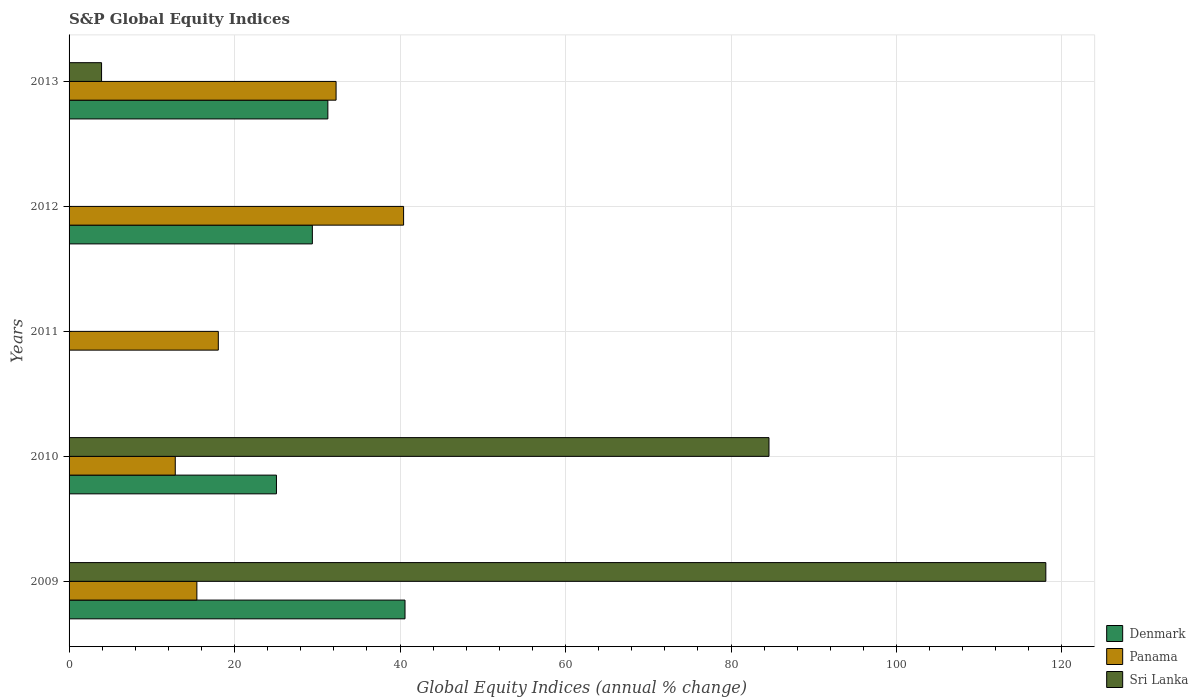How many different coloured bars are there?
Provide a succinct answer. 3. How many bars are there on the 1st tick from the top?
Your answer should be very brief. 3. What is the label of the 4th group of bars from the top?
Your answer should be compact. 2010. What is the global equity indices in Denmark in 2009?
Make the answer very short. 40.6. Across all years, what is the maximum global equity indices in Panama?
Offer a very short reply. 40.43. Across all years, what is the minimum global equity indices in Sri Lanka?
Keep it short and to the point. 0. In which year was the global equity indices in Panama maximum?
Your answer should be very brief. 2012. What is the total global equity indices in Denmark in the graph?
Your answer should be very brief. 126.35. What is the difference between the global equity indices in Panama in 2011 and that in 2012?
Give a very brief answer. -22.39. What is the difference between the global equity indices in Panama in 2009 and the global equity indices in Denmark in 2012?
Your answer should be compact. -13.96. What is the average global equity indices in Panama per year?
Provide a short and direct response. 23.8. In the year 2010, what is the difference between the global equity indices in Sri Lanka and global equity indices in Denmark?
Ensure brevity in your answer.  59.53. In how many years, is the global equity indices in Panama greater than 56 %?
Keep it short and to the point. 0. What is the ratio of the global equity indices in Panama in 2010 to that in 2012?
Your response must be concise. 0.32. Is the global equity indices in Denmark in 2009 less than that in 2010?
Provide a succinct answer. No. What is the difference between the highest and the second highest global equity indices in Sri Lanka?
Offer a terse response. 33.46. What is the difference between the highest and the lowest global equity indices in Panama?
Provide a succinct answer. 27.59. Is it the case that in every year, the sum of the global equity indices in Denmark and global equity indices in Panama is greater than the global equity indices in Sri Lanka?
Your answer should be very brief. No. How many bars are there?
Your response must be concise. 12. Are all the bars in the graph horizontal?
Your response must be concise. Yes. How many years are there in the graph?
Provide a short and direct response. 5. Does the graph contain grids?
Offer a terse response. Yes. Where does the legend appear in the graph?
Your answer should be very brief. Bottom right. How many legend labels are there?
Offer a very short reply. 3. What is the title of the graph?
Keep it short and to the point. S&P Global Equity Indices. Does "Sweden" appear as one of the legend labels in the graph?
Offer a terse response. No. What is the label or title of the X-axis?
Ensure brevity in your answer.  Global Equity Indices (annual % change). What is the Global Equity Indices (annual % change) in Denmark in 2009?
Your answer should be compact. 40.6. What is the Global Equity Indices (annual % change) in Panama in 2009?
Keep it short and to the point. 15.45. What is the Global Equity Indices (annual % change) of Sri Lanka in 2009?
Give a very brief answer. 118.05. What is the Global Equity Indices (annual % change) in Denmark in 2010?
Your answer should be very brief. 25.06. What is the Global Equity Indices (annual % change) of Panama in 2010?
Your answer should be compact. 12.83. What is the Global Equity Indices (annual % change) in Sri Lanka in 2010?
Your answer should be very brief. 84.59. What is the Global Equity Indices (annual % change) of Denmark in 2011?
Your answer should be compact. 0. What is the Global Equity Indices (annual % change) in Panama in 2011?
Your answer should be compact. 18.04. What is the Global Equity Indices (annual % change) in Denmark in 2012?
Keep it short and to the point. 29.4. What is the Global Equity Indices (annual % change) of Panama in 2012?
Offer a very short reply. 40.43. What is the Global Equity Indices (annual % change) of Sri Lanka in 2012?
Make the answer very short. 0. What is the Global Equity Indices (annual % change) in Denmark in 2013?
Offer a very short reply. 31.28. What is the Global Equity Indices (annual % change) in Panama in 2013?
Your answer should be very brief. 32.27. What is the Global Equity Indices (annual % change) in Sri Lanka in 2013?
Give a very brief answer. 3.93. Across all years, what is the maximum Global Equity Indices (annual % change) of Denmark?
Your answer should be very brief. 40.6. Across all years, what is the maximum Global Equity Indices (annual % change) of Panama?
Your answer should be very brief. 40.43. Across all years, what is the maximum Global Equity Indices (annual % change) of Sri Lanka?
Give a very brief answer. 118.05. Across all years, what is the minimum Global Equity Indices (annual % change) of Panama?
Offer a terse response. 12.83. Across all years, what is the minimum Global Equity Indices (annual % change) in Sri Lanka?
Offer a terse response. 0. What is the total Global Equity Indices (annual % change) in Denmark in the graph?
Give a very brief answer. 126.35. What is the total Global Equity Indices (annual % change) of Panama in the graph?
Give a very brief answer. 119.02. What is the total Global Equity Indices (annual % change) in Sri Lanka in the graph?
Your answer should be compact. 206.57. What is the difference between the Global Equity Indices (annual % change) of Denmark in 2009 and that in 2010?
Your answer should be compact. 15.54. What is the difference between the Global Equity Indices (annual % change) of Panama in 2009 and that in 2010?
Your answer should be very brief. 2.61. What is the difference between the Global Equity Indices (annual % change) in Sri Lanka in 2009 and that in 2010?
Your answer should be compact. 33.46. What is the difference between the Global Equity Indices (annual % change) in Panama in 2009 and that in 2011?
Offer a terse response. -2.59. What is the difference between the Global Equity Indices (annual % change) of Denmark in 2009 and that in 2012?
Offer a very short reply. 11.2. What is the difference between the Global Equity Indices (annual % change) in Panama in 2009 and that in 2012?
Offer a terse response. -24.98. What is the difference between the Global Equity Indices (annual % change) in Denmark in 2009 and that in 2013?
Ensure brevity in your answer.  9.33. What is the difference between the Global Equity Indices (annual % change) in Panama in 2009 and that in 2013?
Ensure brevity in your answer.  -16.82. What is the difference between the Global Equity Indices (annual % change) of Sri Lanka in 2009 and that in 2013?
Your answer should be very brief. 114.12. What is the difference between the Global Equity Indices (annual % change) of Panama in 2010 and that in 2011?
Keep it short and to the point. -5.2. What is the difference between the Global Equity Indices (annual % change) in Denmark in 2010 and that in 2012?
Offer a very short reply. -4.34. What is the difference between the Global Equity Indices (annual % change) of Panama in 2010 and that in 2012?
Your response must be concise. -27.59. What is the difference between the Global Equity Indices (annual % change) in Denmark in 2010 and that in 2013?
Give a very brief answer. -6.21. What is the difference between the Global Equity Indices (annual % change) of Panama in 2010 and that in 2013?
Ensure brevity in your answer.  -19.44. What is the difference between the Global Equity Indices (annual % change) in Sri Lanka in 2010 and that in 2013?
Give a very brief answer. 80.66. What is the difference between the Global Equity Indices (annual % change) of Panama in 2011 and that in 2012?
Offer a very short reply. -22.39. What is the difference between the Global Equity Indices (annual % change) of Panama in 2011 and that in 2013?
Your answer should be compact. -14.23. What is the difference between the Global Equity Indices (annual % change) of Denmark in 2012 and that in 2013?
Ensure brevity in your answer.  -1.87. What is the difference between the Global Equity Indices (annual % change) in Panama in 2012 and that in 2013?
Your answer should be very brief. 8.16. What is the difference between the Global Equity Indices (annual % change) in Denmark in 2009 and the Global Equity Indices (annual % change) in Panama in 2010?
Provide a short and direct response. 27.77. What is the difference between the Global Equity Indices (annual % change) in Denmark in 2009 and the Global Equity Indices (annual % change) in Sri Lanka in 2010?
Provide a short and direct response. -43.99. What is the difference between the Global Equity Indices (annual % change) of Panama in 2009 and the Global Equity Indices (annual % change) of Sri Lanka in 2010?
Offer a terse response. -69.14. What is the difference between the Global Equity Indices (annual % change) in Denmark in 2009 and the Global Equity Indices (annual % change) in Panama in 2011?
Offer a terse response. 22.57. What is the difference between the Global Equity Indices (annual % change) of Denmark in 2009 and the Global Equity Indices (annual % change) of Panama in 2012?
Give a very brief answer. 0.17. What is the difference between the Global Equity Indices (annual % change) of Denmark in 2009 and the Global Equity Indices (annual % change) of Panama in 2013?
Give a very brief answer. 8.33. What is the difference between the Global Equity Indices (annual % change) of Denmark in 2009 and the Global Equity Indices (annual % change) of Sri Lanka in 2013?
Offer a terse response. 36.67. What is the difference between the Global Equity Indices (annual % change) in Panama in 2009 and the Global Equity Indices (annual % change) in Sri Lanka in 2013?
Make the answer very short. 11.52. What is the difference between the Global Equity Indices (annual % change) in Denmark in 2010 and the Global Equity Indices (annual % change) in Panama in 2011?
Provide a succinct answer. 7.03. What is the difference between the Global Equity Indices (annual % change) in Denmark in 2010 and the Global Equity Indices (annual % change) in Panama in 2012?
Give a very brief answer. -15.37. What is the difference between the Global Equity Indices (annual % change) of Denmark in 2010 and the Global Equity Indices (annual % change) of Panama in 2013?
Provide a short and direct response. -7.21. What is the difference between the Global Equity Indices (annual % change) in Denmark in 2010 and the Global Equity Indices (annual % change) in Sri Lanka in 2013?
Provide a succinct answer. 21.14. What is the difference between the Global Equity Indices (annual % change) in Panama in 2010 and the Global Equity Indices (annual % change) in Sri Lanka in 2013?
Ensure brevity in your answer.  8.91. What is the difference between the Global Equity Indices (annual % change) of Panama in 2011 and the Global Equity Indices (annual % change) of Sri Lanka in 2013?
Your answer should be compact. 14.11. What is the difference between the Global Equity Indices (annual % change) in Denmark in 2012 and the Global Equity Indices (annual % change) in Panama in 2013?
Keep it short and to the point. -2.87. What is the difference between the Global Equity Indices (annual % change) of Denmark in 2012 and the Global Equity Indices (annual % change) of Sri Lanka in 2013?
Your answer should be compact. 25.48. What is the difference between the Global Equity Indices (annual % change) in Panama in 2012 and the Global Equity Indices (annual % change) in Sri Lanka in 2013?
Provide a succinct answer. 36.5. What is the average Global Equity Indices (annual % change) in Denmark per year?
Give a very brief answer. 25.27. What is the average Global Equity Indices (annual % change) of Panama per year?
Make the answer very short. 23.8. What is the average Global Equity Indices (annual % change) in Sri Lanka per year?
Offer a terse response. 41.31. In the year 2009, what is the difference between the Global Equity Indices (annual % change) in Denmark and Global Equity Indices (annual % change) in Panama?
Your answer should be compact. 25.16. In the year 2009, what is the difference between the Global Equity Indices (annual % change) of Denmark and Global Equity Indices (annual % change) of Sri Lanka?
Offer a very short reply. -77.45. In the year 2009, what is the difference between the Global Equity Indices (annual % change) in Panama and Global Equity Indices (annual % change) in Sri Lanka?
Your answer should be very brief. -102.6. In the year 2010, what is the difference between the Global Equity Indices (annual % change) of Denmark and Global Equity Indices (annual % change) of Panama?
Your answer should be very brief. 12.23. In the year 2010, what is the difference between the Global Equity Indices (annual % change) in Denmark and Global Equity Indices (annual % change) in Sri Lanka?
Give a very brief answer. -59.53. In the year 2010, what is the difference between the Global Equity Indices (annual % change) in Panama and Global Equity Indices (annual % change) in Sri Lanka?
Make the answer very short. -71.76. In the year 2012, what is the difference between the Global Equity Indices (annual % change) of Denmark and Global Equity Indices (annual % change) of Panama?
Your answer should be very brief. -11.03. In the year 2013, what is the difference between the Global Equity Indices (annual % change) of Denmark and Global Equity Indices (annual % change) of Panama?
Offer a very short reply. -0.99. In the year 2013, what is the difference between the Global Equity Indices (annual % change) in Denmark and Global Equity Indices (annual % change) in Sri Lanka?
Offer a terse response. 27.35. In the year 2013, what is the difference between the Global Equity Indices (annual % change) in Panama and Global Equity Indices (annual % change) in Sri Lanka?
Give a very brief answer. 28.34. What is the ratio of the Global Equity Indices (annual % change) of Denmark in 2009 to that in 2010?
Ensure brevity in your answer.  1.62. What is the ratio of the Global Equity Indices (annual % change) of Panama in 2009 to that in 2010?
Give a very brief answer. 1.2. What is the ratio of the Global Equity Indices (annual % change) of Sri Lanka in 2009 to that in 2010?
Make the answer very short. 1.4. What is the ratio of the Global Equity Indices (annual % change) of Panama in 2009 to that in 2011?
Your response must be concise. 0.86. What is the ratio of the Global Equity Indices (annual % change) of Denmark in 2009 to that in 2012?
Ensure brevity in your answer.  1.38. What is the ratio of the Global Equity Indices (annual % change) in Panama in 2009 to that in 2012?
Keep it short and to the point. 0.38. What is the ratio of the Global Equity Indices (annual % change) of Denmark in 2009 to that in 2013?
Your answer should be compact. 1.3. What is the ratio of the Global Equity Indices (annual % change) in Panama in 2009 to that in 2013?
Offer a terse response. 0.48. What is the ratio of the Global Equity Indices (annual % change) in Sri Lanka in 2009 to that in 2013?
Offer a terse response. 30.06. What is the ratio of the Global Equity Indices (annual % change) in Panama in 2010 to that in 2011?
Give a very brief answer. 0.71. What is the ratio of the Global Equity Indices (annual % change) of Denmark in 2010 to that in 2012?
Keep it short and to the point. 0.85. What is the ratio of the Global Equity Indices (annual % change) in Panama in 2010 to that in 2012?
Give a very brief answer. 0.32. What is the ratio of the Global Equity Indices (annual % change) of Denmark in 2010 to that in 2013?
Your answer should be compact. 0.8. What is the ratio of the Global Equity Indices (annual % change) in Panama in 2010 to that in 2013?
Offer a very short reply. 0.4. What is the ratio of the Global Equity Indices (annual % change) in Sri Lanka in 2010 to that in 2013?
Give a very brief answer. 21.54. What is the ratio of the Global Equity Indices (annual % change) in Panama in 2011 to that in 2012?
Offer a terse response. 0.45. What is the ratio of the Global Equity Indices (annual % change) of Panama in 2011 to that in 2013?
Make the answer very short. 0.56. What is the ratio of the Global Equity Indices (annual % change) in Denmark in 2012 to that in 2013?
Provide a short and direct response. 0.94. What is the ratio of the Global Equity Indices (annual % change) in Panama in 2012 to that in 2013?
Provide a succinct answer. 1.25. What is the difference between the highest and the second highest Global Equity Indices (annual % change) of Denmark?
Give a very brief answer. 9.33. What is the difference between the highest and the second highest Global Equity Indices (annual % change) in Panama?
Your answer should be compact. 8.16. What is the difference between the highest and the second highest Global Equity Indices (annual % change) in Sri Lanka?
Your answer should be very brief. 33.46. What is the difference between the highest and the lowest Global Equity Indices (annual % change) in Denmark?
Your response must be concise. 40.6. What is the difference between the highest and the lowest Global Equity Indices (annual % change) of Panama?
Ensure brevity in your answer.  27.59. What is the difference between the highest and the lowest Global Equity Indices (annual % change) of Sri Lanka?
Your response must be concise. 118.05. 